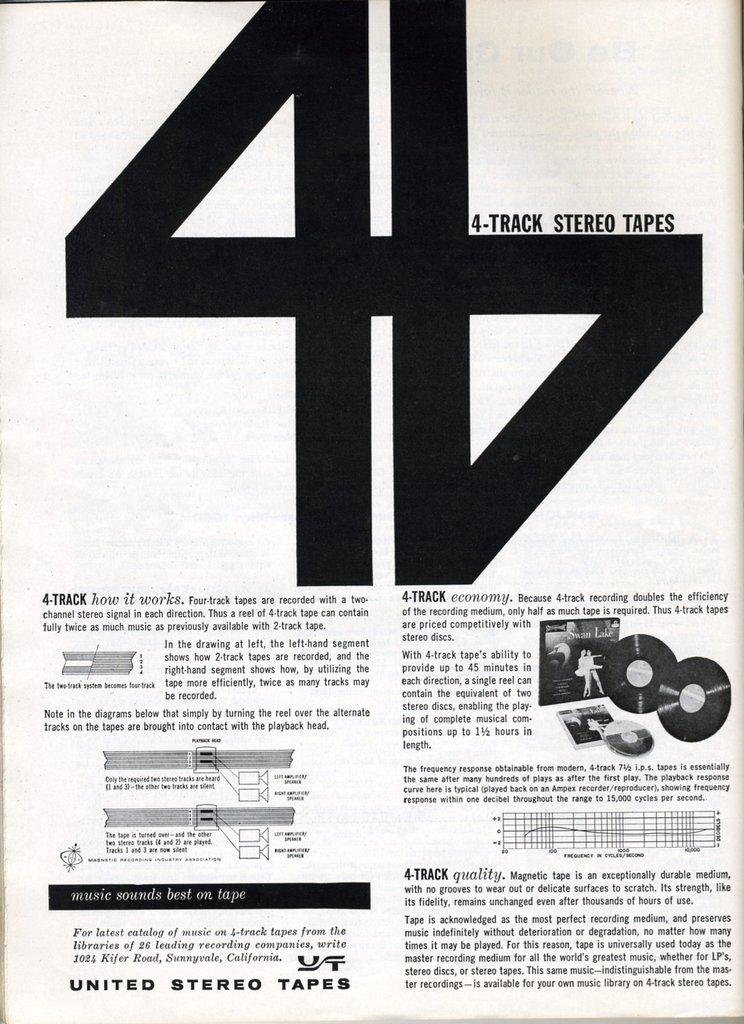What are the three words on the bottom left?
Provide a short and direct response. United stereo tapes. How many records on the poster?
Your answer should be very brief. 2. 